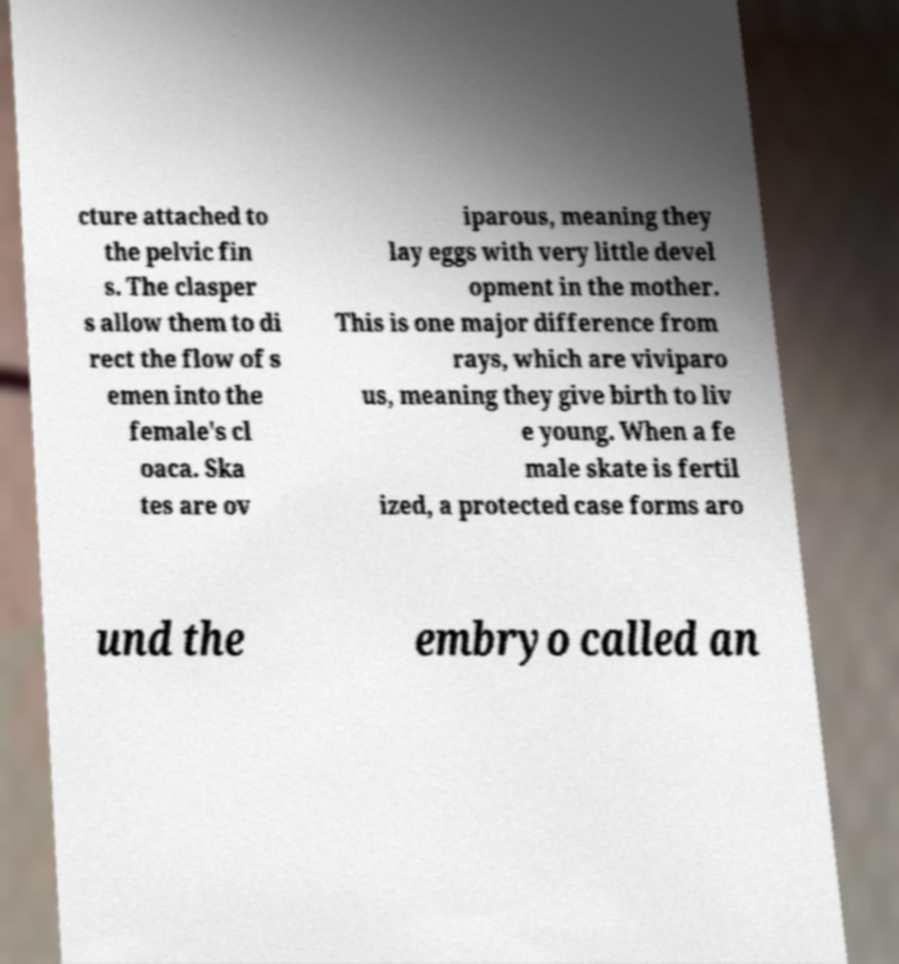Could you extract and type out the text from this image? cture attached to the pelvic fin s. The clasper s allow them to di rect the flow of s emen into the female's cl oaca. Ska tes are ov iparous, meaning they lay eggs with very little devel opment in the mother. This is one major difference from rays, which are viviparo us, meaning they give birth to liv e young. When a fe male skate is fertil ized, a protected case forms aro und the embryo called an 